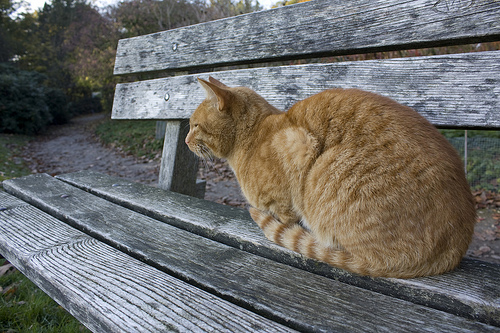What's in front of the path? There is a bench positioned in front of the path. 